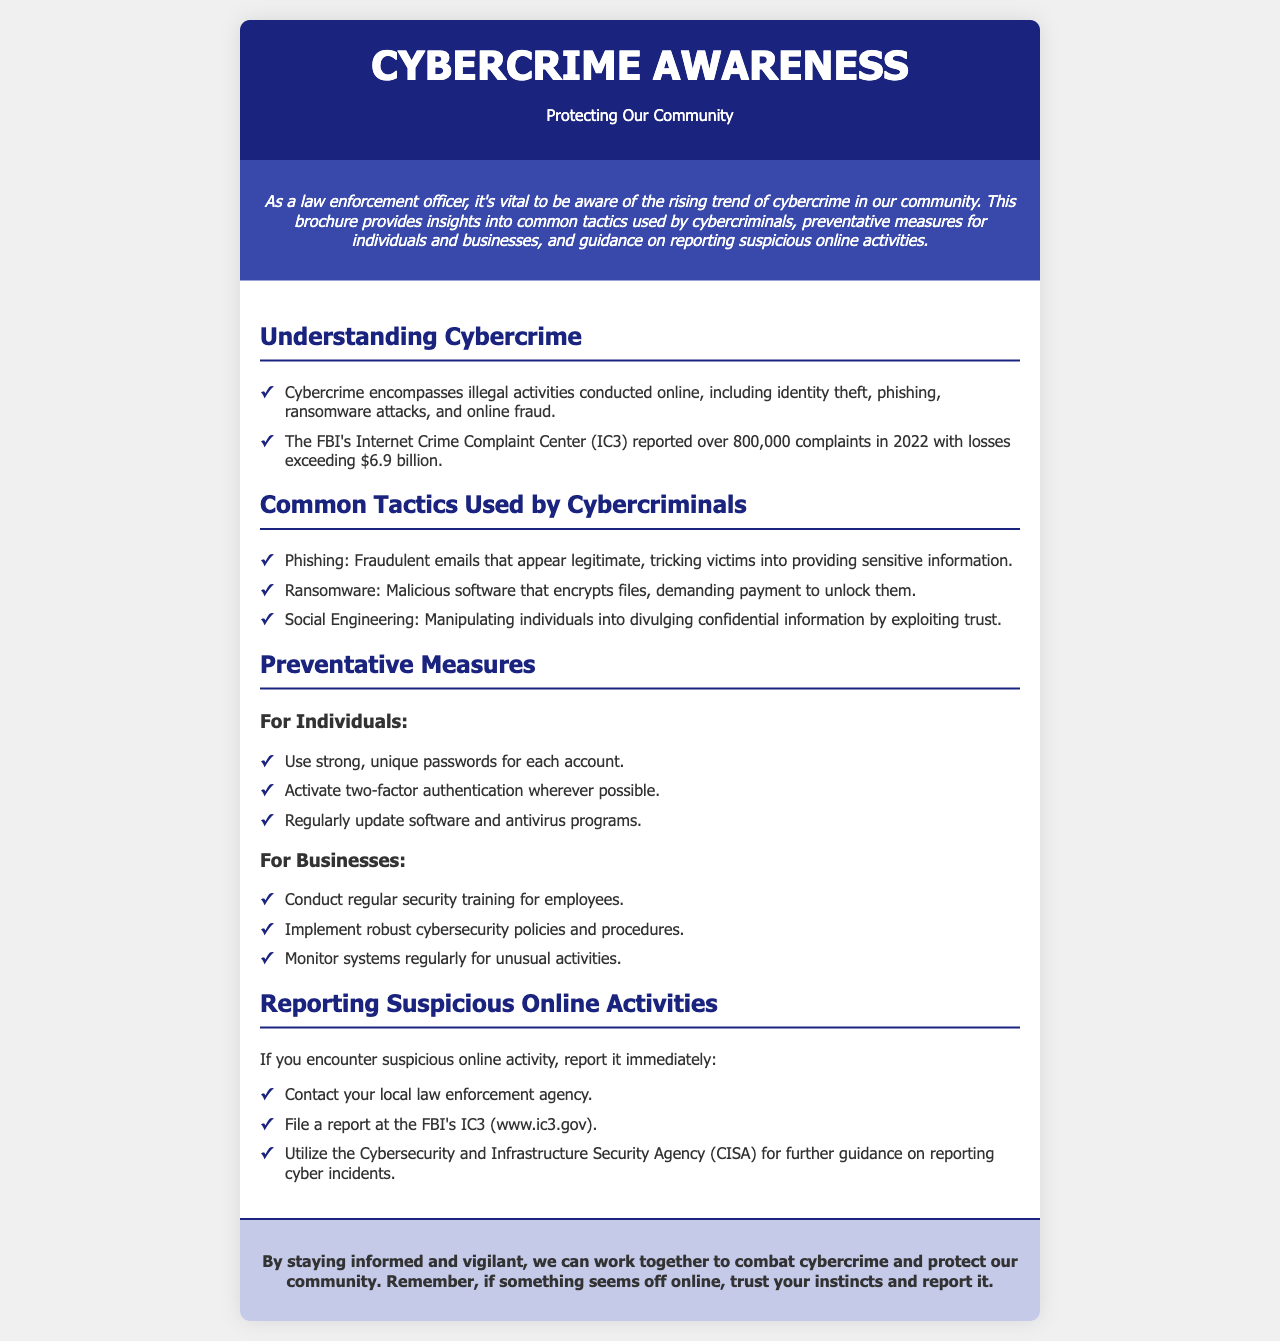What is the title of the brochure? The title is explicitly stated in the header of the document.
Answer: Cybercrime Awareness What year did the FBI report over 800,000 complaints? The complaint report is referenced within the context of the document's statistics.
Answer: 2022 What is one common tactic used by cybercriminals? The document lists several tactics in a structured format.
Answer: Phishing How many billions were lost due to cybercrime in 2022, according to the report? The total loss figure is provided in the content section.
Answer: $6.9 billion What is one preventative measure for individuals? The document provides specific suggestions for individuals in a bullet list format.
Answer: Use strong, unique passwords Who should you contact to report suspicious online activities? The document outlines reporting agencies and procedures in the relevant section.
Answer: Local law enforcement agency What does ransomware do? The document describes the primary effect of this tactic used by cybercriminals.
Answer: Encrypts files What agency can you file a report with regarding cybercrime? This is mentioned in the reporting section of the document.
Answer: FBI's IC3 What is emphasized at the end of the brochure? The conclusion of the document provides a final call to action.
Answer: Trust your instincts 